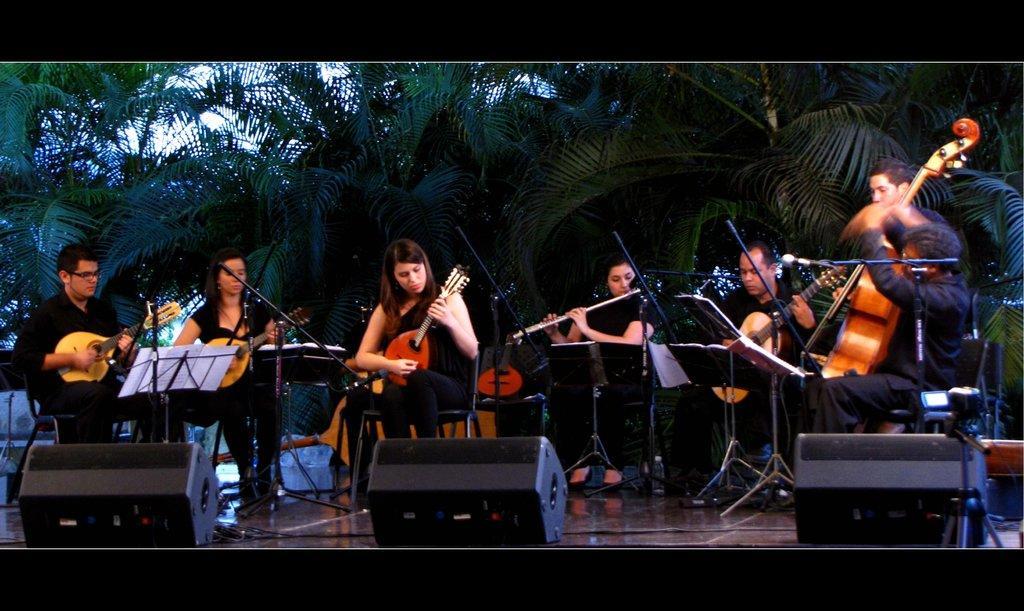Can you describe this image briefly? In this picture we can see some persons are sitting on the chairs. They are playing guitar. This is floor. On the background there are trees. 